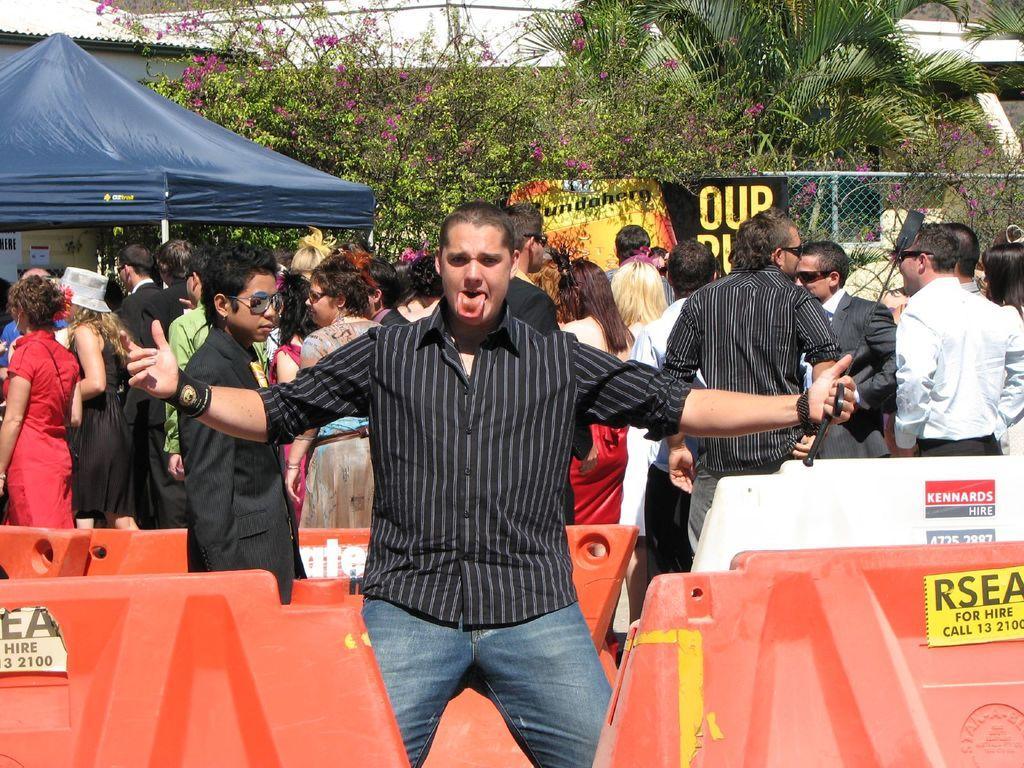Please provide a concise description of this image. In the image there is a man in the foreground, he is giving a weird expression and around him there are some orange colour objects, behind the man there is a crowd, a tent, a poster, mesh and trees. 